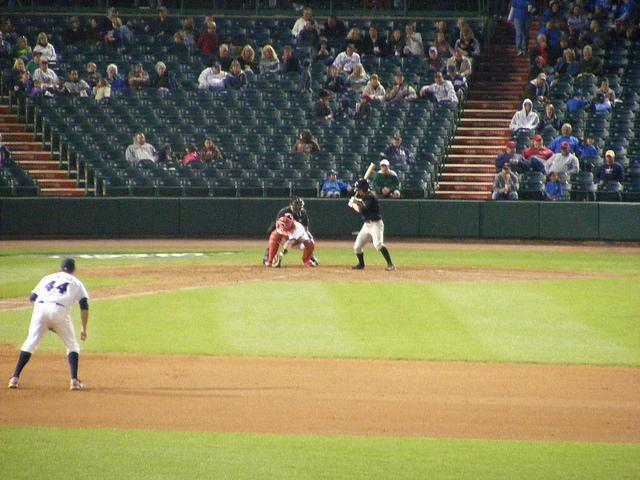How does the temperature likely feel?
Select the correct answer and articulate reasoning with the following format: 'Answer: answer
Rationale: rationale.'
Options: Cold, hot, warm, cool. Answer: cool.
Rationale: Judging by the clothing being worn by the people in the stands, they are wearing more clothing than one would on a warm day, but less that one would on a very cold day so the temperature is likely in the middle. 